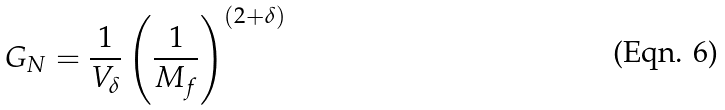Convert formula to latex. <formula><loc_0><loc_0><loc_500><loc_500>G _ { N } = \frac { 1 } { V _ { \delta } } \left ( \frac { 1 } { M _ { f } } \right ) ^ { ( 2 + \delta ) }</formula> 